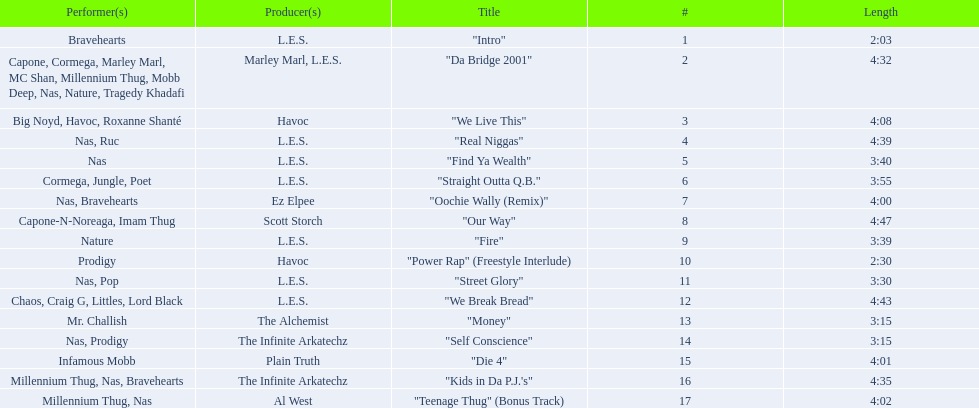What are all the songs on the album? "Intro", "Da Bridge 2001", "We Live This", "Real Niggas", "Find Ya Wealth", "Straight Outta Q.B.", "Oochie Wally (Remix)", "Our Way", "Fire", "Power Rap" (Freestyle Interlude), "Street Glory", "We Break Bread", "Money", "Self Conscience", "Die 4", "Kids in Da P.J.'s", "Teenage Thug" (Bonus Track). Which is the shortest? "Intro". How long is that song? 2:03. 